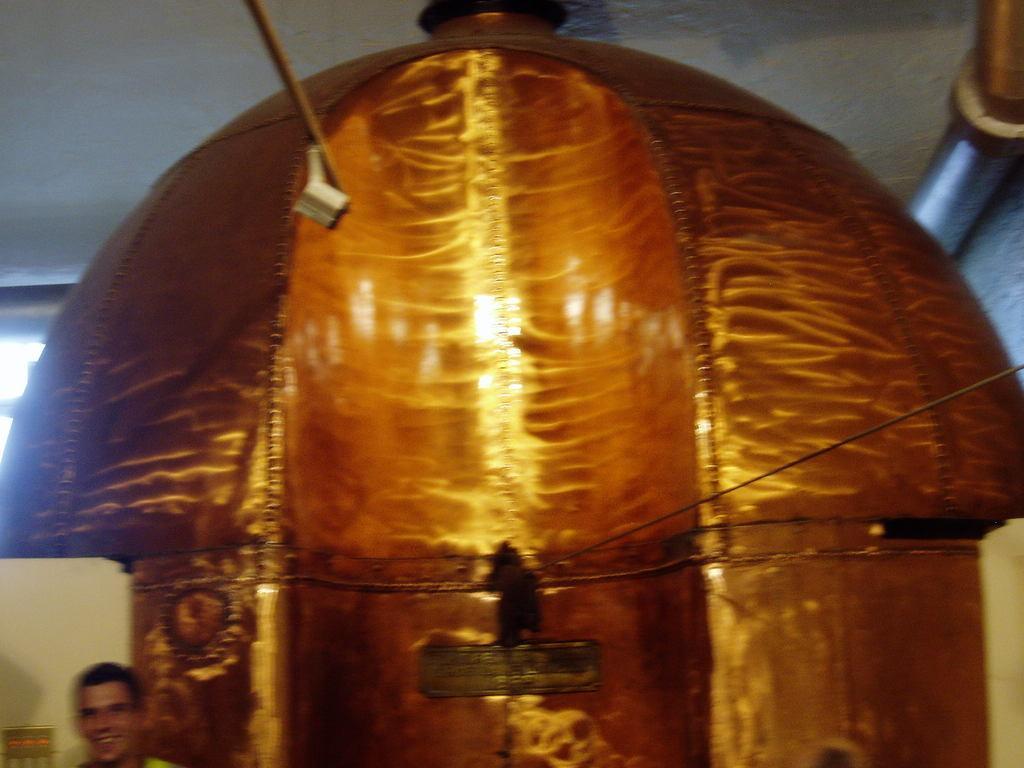Describe this image in one or two sentences. In this image we can see object which is in golden color and a person standing near the object. 